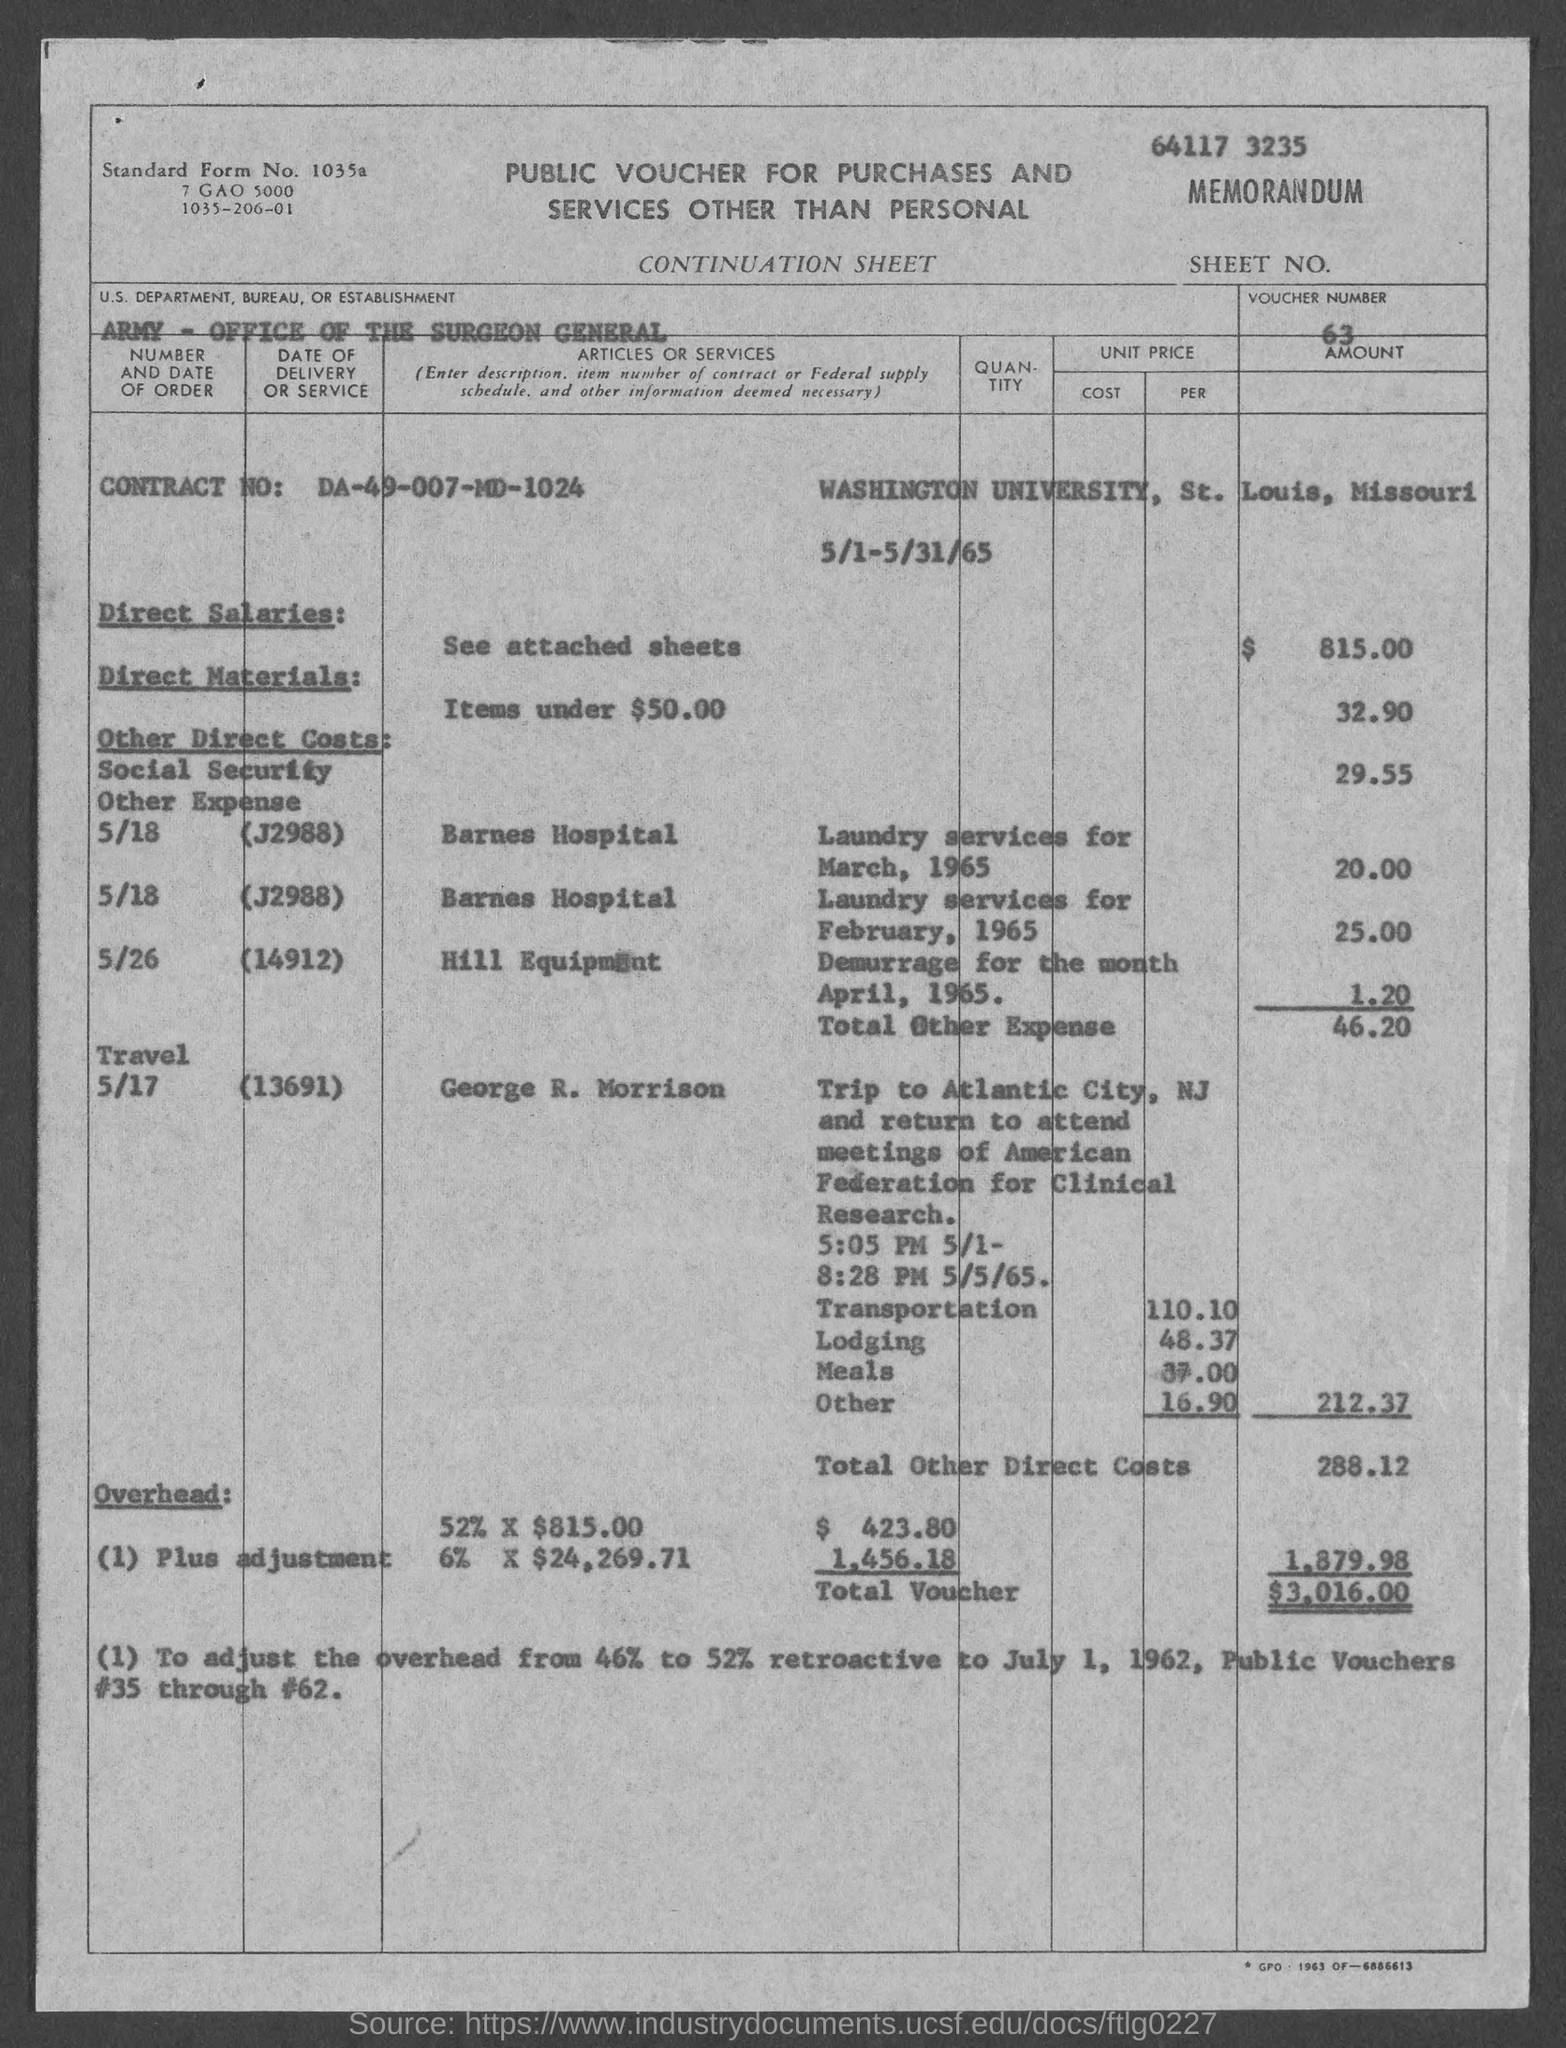Highlight a few significant elements in this photo. What is the contract number?" DA-49-007-MD-1024... The total voucher amount is $3,016.00. The voucher number is 63. The Department, Bureau, or Establishment mentioned in the voucher is the Army - Office of the Surgeon General. 